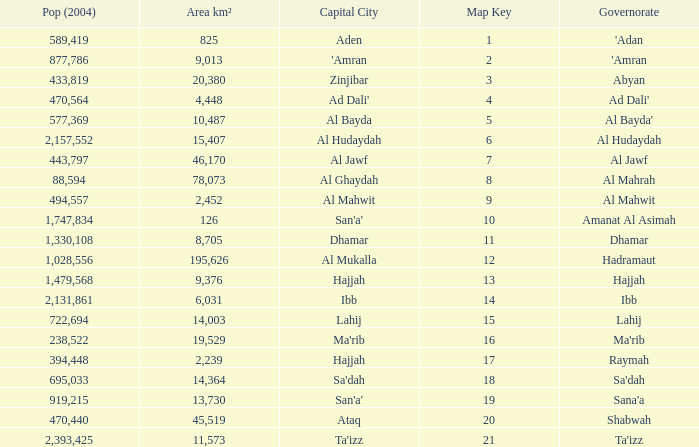How many Pop (2004) has a Governorate of al mahwit? 494557.0. 